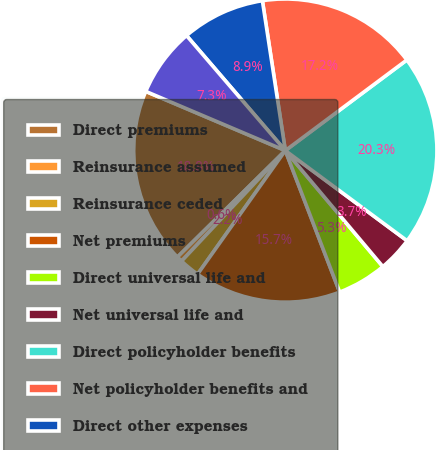<chart> <loc_0><loc_0><loc_500><loc_500><pie_chart><fcel>Direct premiums<fcel>Reinsurance assumed<fcel>Reinsurance ceded<fcel>Net premiums<fcel>Direct universal life and<fcel>Net universal life and<fcel>Direct policyholder benefits<fcel>Net policyholder benefits and<fcel>Direct other expenses<fcel>Net other expenses<nl><fcel>18.78%<fcel>0.61%<fcel>2.17%<fcel>15.66%<fcel>5.29%<fcel>3.73%<fcel>20.34%<fcel>17.22%<fcel>8.88%<fcel>7.32%<nl></chart> 